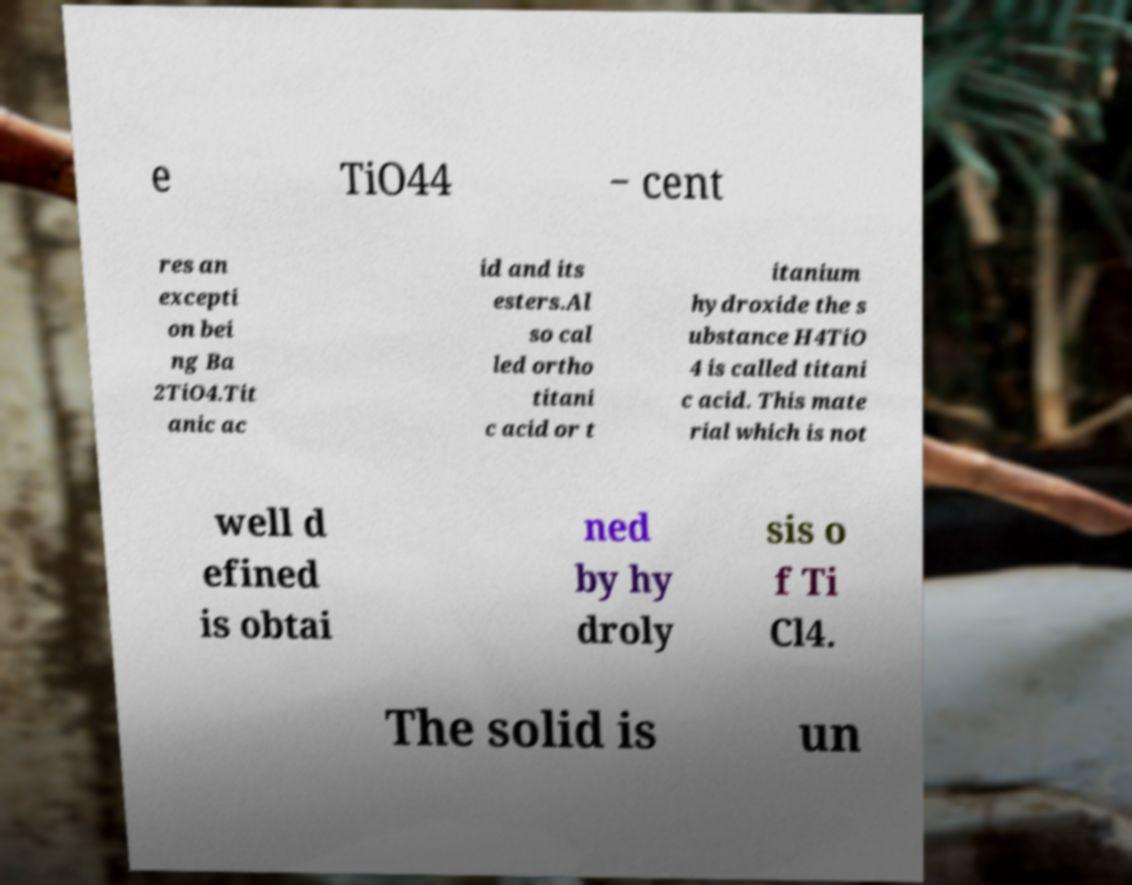Could you extract and type out the text from this image? e TiO44 − cent res an excepti on bei ng Ba 2TiO4.Tit anic ac id and its esters.Al so cal led ortho titani c acid or t itanium hydroxide the s ubstance H4TiO 4 is called titani c acid. This mate rial which is not well d efined is obtai ned by hy droly sis o f Ti Cl4. The solid is un 